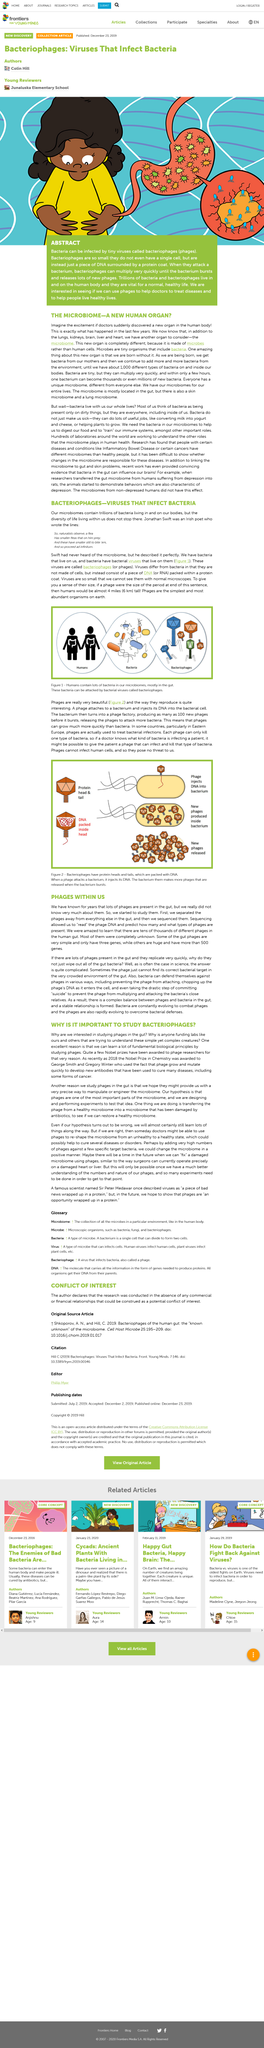Highlight a few significant elements in this photo. Jonathan Swift was an Irish poet who is known for his literary works. Phages are used in Eastern European countries to treat bacterial infections. Phages are viruses that infect bacteria. Their method of reproduction is by attaching to a bacterium and injecting their DNA into the bacterial cell. The bacterium then converts into a phage factory, producing as many as 100 new phages before bursting, releasing the phages to attack more bacteria. The Microbiome is a new human organ that is essential for overall health. The microbiome is primarily located in the gut, but it also exists in the skin and lungs. 